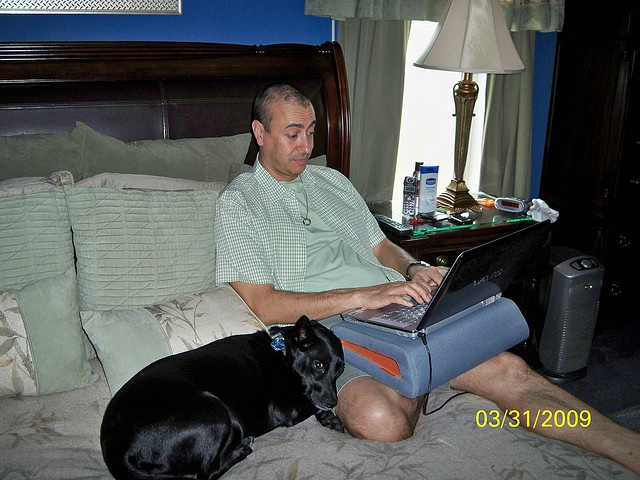Describe the objects in this image and their specific colors. I can see bed in lightgray, darkgray, and gray tones, people in lightgray, darkgray, gray, and tan tones, dog in lightgray, black, gray, and darkblue tones, laptop in lightgray, black, and gray tones, and clock in lightgray, gray, black, and darkgray tones in this image. 